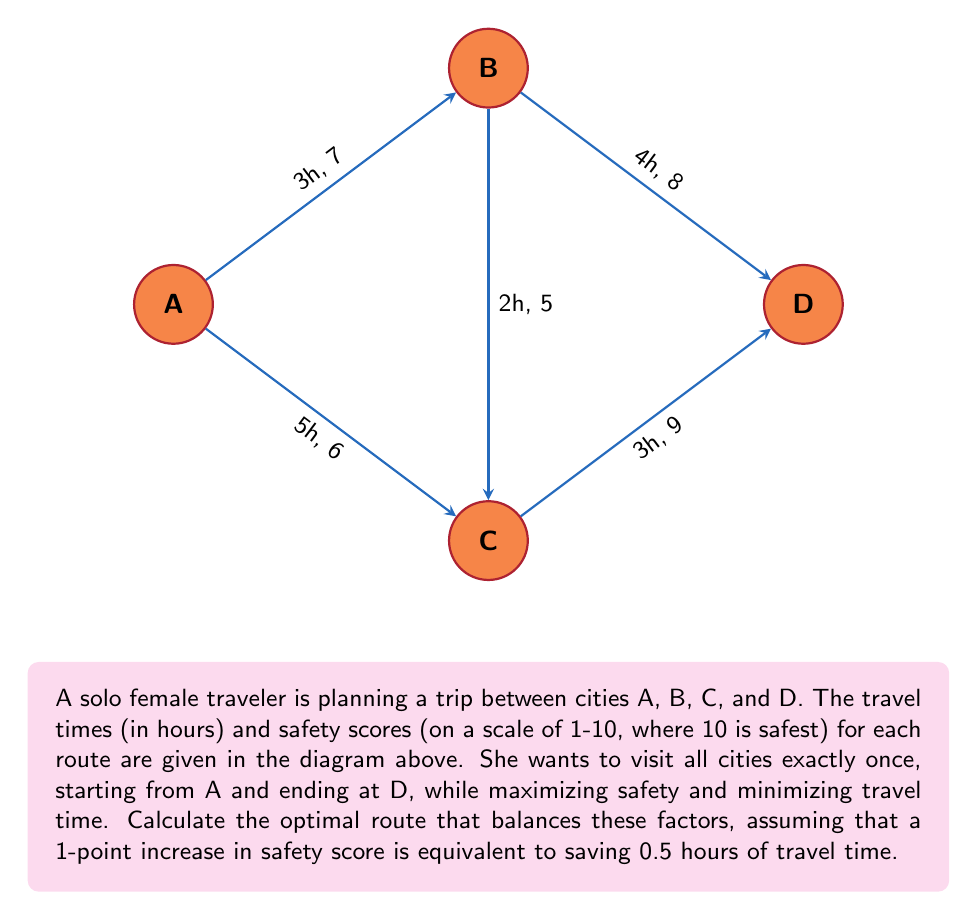Provide a solution to this math problem. Let's approach this step-by-step:

1) First, we need to calculate an "adjusted travel time" for each route, where we subtract 0.5 hours for each point of safety above 1. The formula is:

   $\text{Adjusted Time} = \text{Actual Time} - 0.5 \times (\text{Safety Score} - 1)$

2) Calculate the adjusted time for each route:
   A to B: $3 - 0.5 \times (7 - 1) = 0$ hours
   A to C: $5 - 0.5 \times (6 - 1) = 2.5$ hours
   B to C: $2 - 0.5 \times (5 - 1) = 0$ hours
   B to D: $4 - 0.5 \times (8 - 1) = 0.5$ hours
   C to D: $3 - 0.5 \times (9 - 1) = -1$ hour

3) Now we need to find the shortest path from A to D visiting B and C exactly once. We have two possible routes:
   
   Route 1: A → B → C → D
   Route 2: A → C → B → D

4) Calculate the total adjusted time for each route:

   Route 1: A → B → C → D
   Total = 0 + 0 + (-1) = -1 hour

   Route 2: A → C → B → D
   Total = 2.5 + 0 + 0.5 = 3 hours

5) The route with the lowest adjusted time is optimal. In this case, it's Route 1: A → B → C → D.
Answer: A → B → C → D 